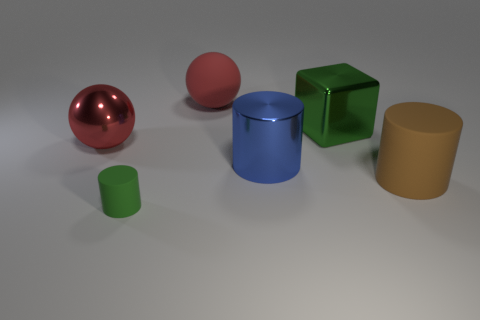Is the number of tiny green objects behind the brown matte object greater than the number of brown matte cylinders?
Keep it short and to the point. No. What number of tiny cylinders are on the right side of the big ball behind the large red ball in front of the large matte ball?
Make the answer very short. 0. Do the red ball that is right of the metal sphere and the green object in front of the big red shiny sphere have the same size?
Provide a succinct answer. No. There is a big red ball that is to the left of the green object that is on the left side of the big blue metal cylinder; what is it made of?
Offer a terse response. Metal. How many things are either large spheres in front of the big green cube or rubber things?
Give a very brief answer. 4. Are there the same number of blue cylinders that are right of the large rubber cylinder and big red spheres that are in front of the tiny cylinder?
Your response must be concise. Yes. What is the material of the green thing that is on the right side of the big cylinder that is behind the big matte thing that is to the right of the large rubber ball?
Offer a very short reply. Metal. There is a shiny object that is right of the big red matte ball and in front of the green metal block; what is its size?
Provide a succinct answer. Large. Does the red metallic thing have the same shape as the brown thing?
Offer a terse response. No. The blue thing that is made of the same material as the big block is what shape?
Provide a short and direct response. Cylinder. 